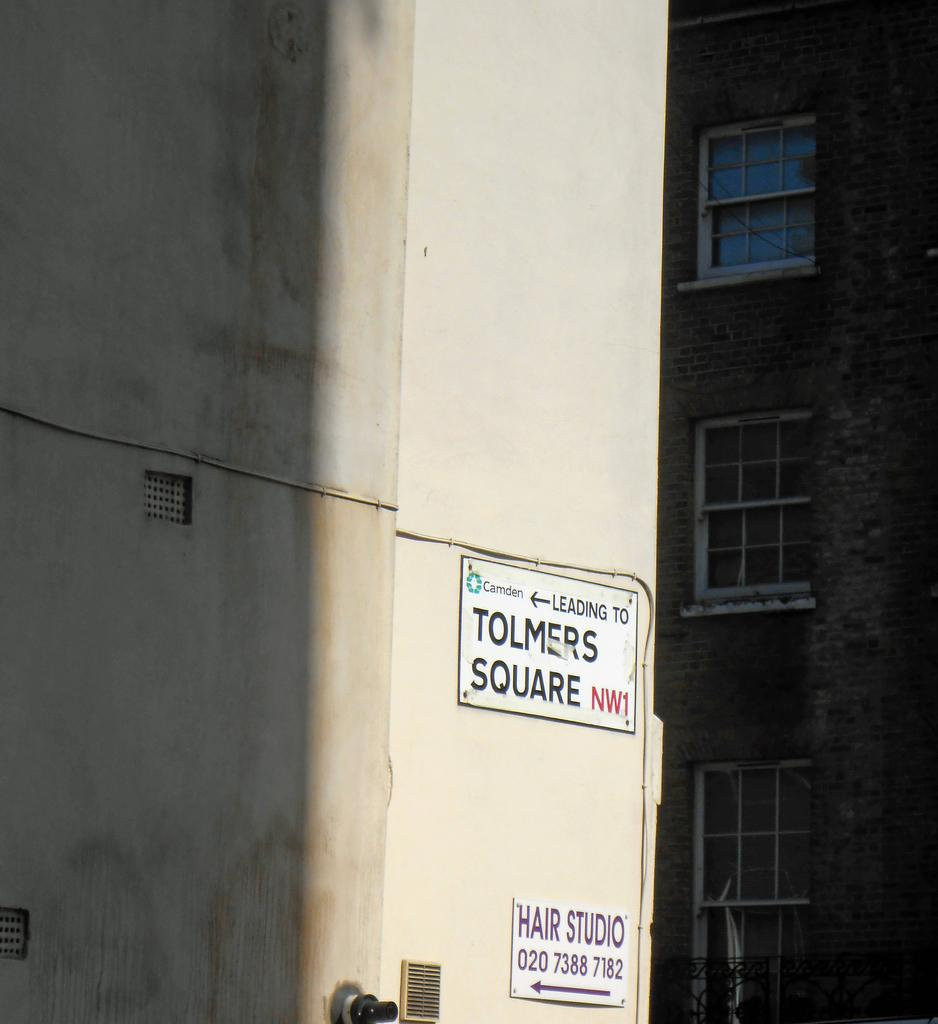What can be seen on the two boards in the image? There are two boards with text in the image. Where are the boards located? The boards are attached to a building. What else can be seen in the image besides the boards? There is another building in front of the first building. What type of skin condition is visible on the boards in the image? There is no skin condition visible on the boards in the image; they have text on them. What type of lettuce can be seen growing on the boards in the image? There is no lettuce present in the image; it features two boards with text attached to a building. 